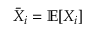<formula> <loc_0><loc_0><loc_500><loc_500>\bar { X } _ { i } = \mathbb { E } [ X _ { i } ]</formula> 